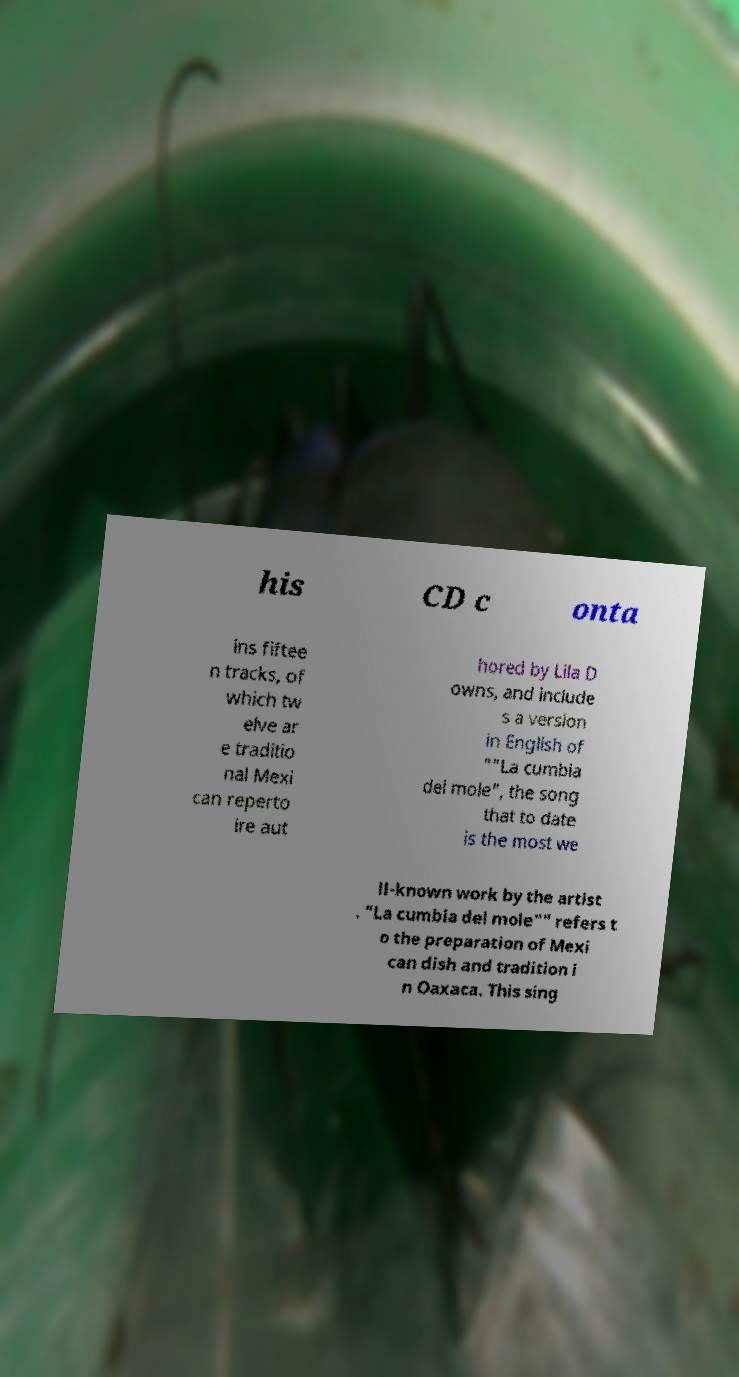Can you accurately transcribe the text from the provided image for me? his CD c onta ins fiftee n tracks, of which tw elve ar e traditio nal Mexi can reperto ire aut hored by Lila D owns, and include s a version in English of ""La cumbia del mole", the song that to date is the most we ll-known work by the artist . "La cumbia del mole"" refers t o the preparation of Mexi can dish and tradition i n Oaxaca. This sing 